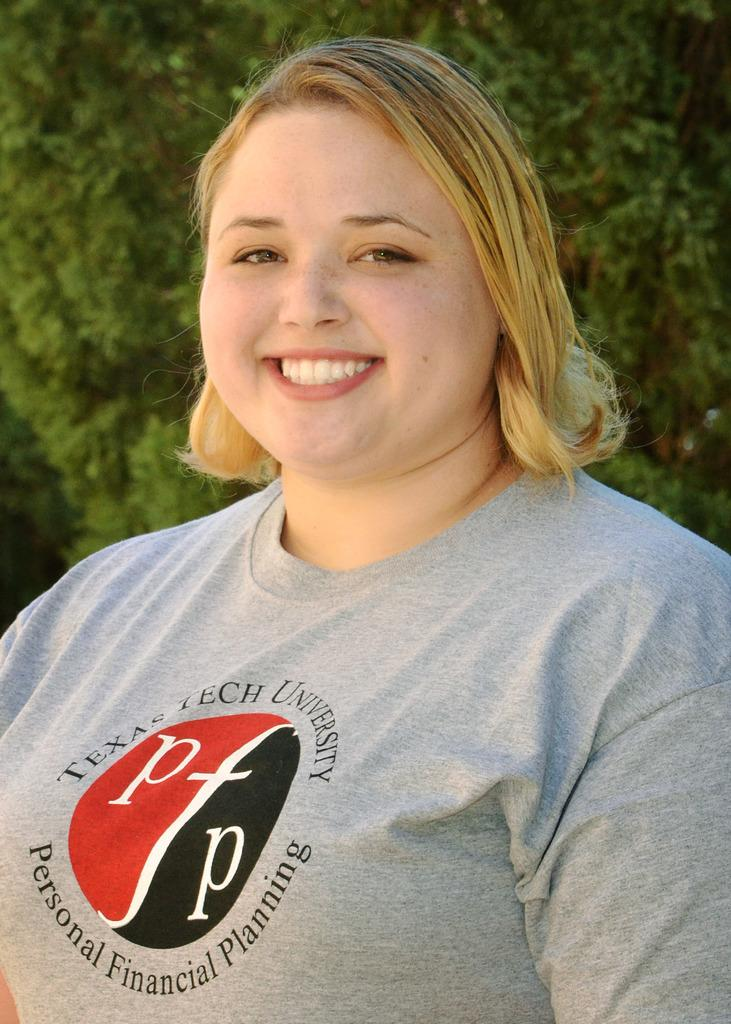What is the main subject of the image? There is a person in the image. What else can be seen in the image besides the person? There is a plant in the image. Can you describe the clothing of the person in the image? There is text on a T-shirt in the image. What type of bed can be seen in the image? There is no bed present in the image. 